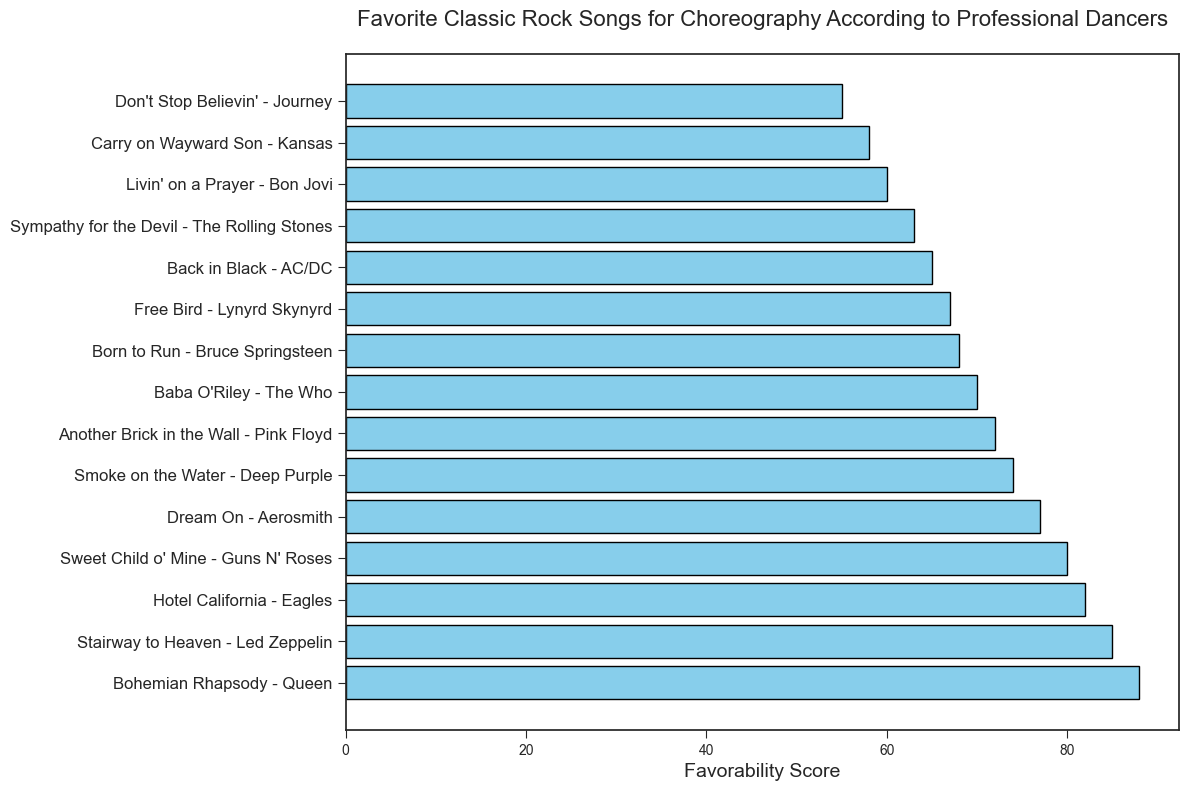which song has the highest favorability score? The bar chart shows that "Bohemian Rhapsody - Queen" has the highest favorability score based on the length of the bars.
Answer: Bohemian Rhapsody - Queen Which song received the lowest favorability score? The bar chart shows that the song with the shortest bar is "Don't Stop Believin' - Journey," indicating it has the lowest favorability score.
Answer: Don't Stop Believin' - Journey How many songs have scores greater than or equal to 80? To determine how many songs have scores greater than or equal to 80, count the bars that reach or exceed the 80 mark on the x-axis. The songs are "Bohemian Rhapsody - Queen," "Stairway to Heaven - Led Zeppelin," "Hotel California - Eagles," and "Sweet Child o' Mine - Guns N' Roses."
Answer: 4 What is the difference in favorability scores between "Bohemian Rhapsody - Queen" and "Don't Stop Believin' - Journey"? Find the favorability scores of both songs and subtract the smaller number from the larger one. The score for "Bohemian Rhapsody - Queen" is 88, and for "Don't Stop Believin' - Journey," it is 55. The difference is 88 - 55.
Answer: 33 Which song scored higher: "Smoke on the Water - Deep Purple" or "Livin' on a Prayer - Bon Jovi"? Compare the favorability scores of the two songs. "Smoke on the Water - Deep Purple" has a score of 74, while "Livin' on a Prayer - Bon Jovi" has a score of 60.
Answer: Smoke on the Water - Deep Purple What is the combined favorability score of the top three songs? To find the combined favorability score, add the scores of the top three songs: "Bohemian Rhapsody - Queen" (88), "Stairway to Heaven - Led Zeppelin" (85), and "Hotel California - Eagles" (82). The total is 88 + 85 + 82.
Answer: 255 Which song has a favorability score closest to the average score? First, find the average of all the favorability scores by summing them and dividing by the number of songs. Then, identify the song with a score closest to this average. The average is (88+85+82+80+77+74+72+70+68+67+65+63+60+58+55)/15 = 72.73. "Another Brick in the Wall - Pink Floyd" has a score of 72, which is closest to the average.
Answer: Another Brick in the Wall - Pink Floyd Which songs have favorability scores within 5 points above or below the median score? Calculate the median score by arranging all favorability scores in ascending order and finding the middle value. The median score is 70. Songs within 5 points above or below are those with scores between 65 and 75. These songs are "Smoke on the Water - Deep Purple" (74), "Another Brick in the Wall - Pink Floyd" (72), "Baba O'Riley - The Who" (70), "Born to Run - Bruce Springsteen" (68), and "Free Bird - Lynyrd Skynyrd" (67).
Answer: Smoke on the Water - Deep Purple, Another Brick in the Wall - Pink Floyd, Baba O'Riley - The Who, Born to Run - Bruce Springsteen, Free Bird - Lynyrd Skynyrd Between "Born to Run - Bruce Springsteen" and "Sympathy for the Devil - The Rolling Stones", how much higher is the favorability score of the higher-rated song? Identify the scores of both songs. "Born to Run - Bruce Springsteen" has 68, and "Sympathy for the Devil - The Rolling Stones" has 63. The difference is 68 - 63.
Answer: 5 